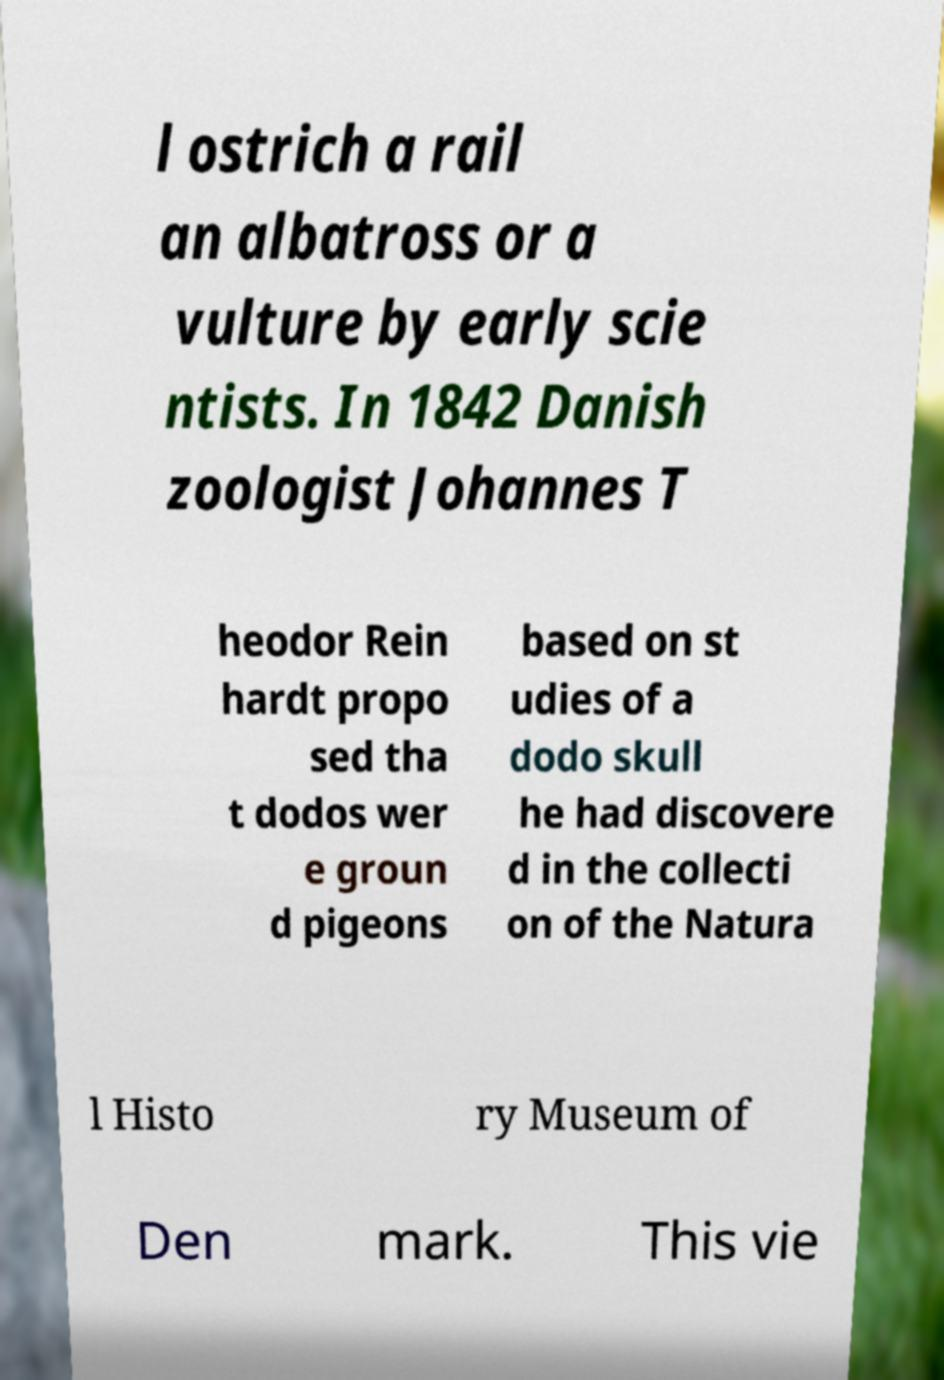Please read and relay the text visible in this image. What does it say? l ostrich a rail an albatross or a vulture by early scie ntists. In 1842 Danish zoologist Johannes T heodor Rein hardt propo sed tha t dodos wer e groun d pigeons based on st udies of a dodo skull he had discovere d in the collecti on of the Natura l Histo ry Museum of Den mark. This vie 